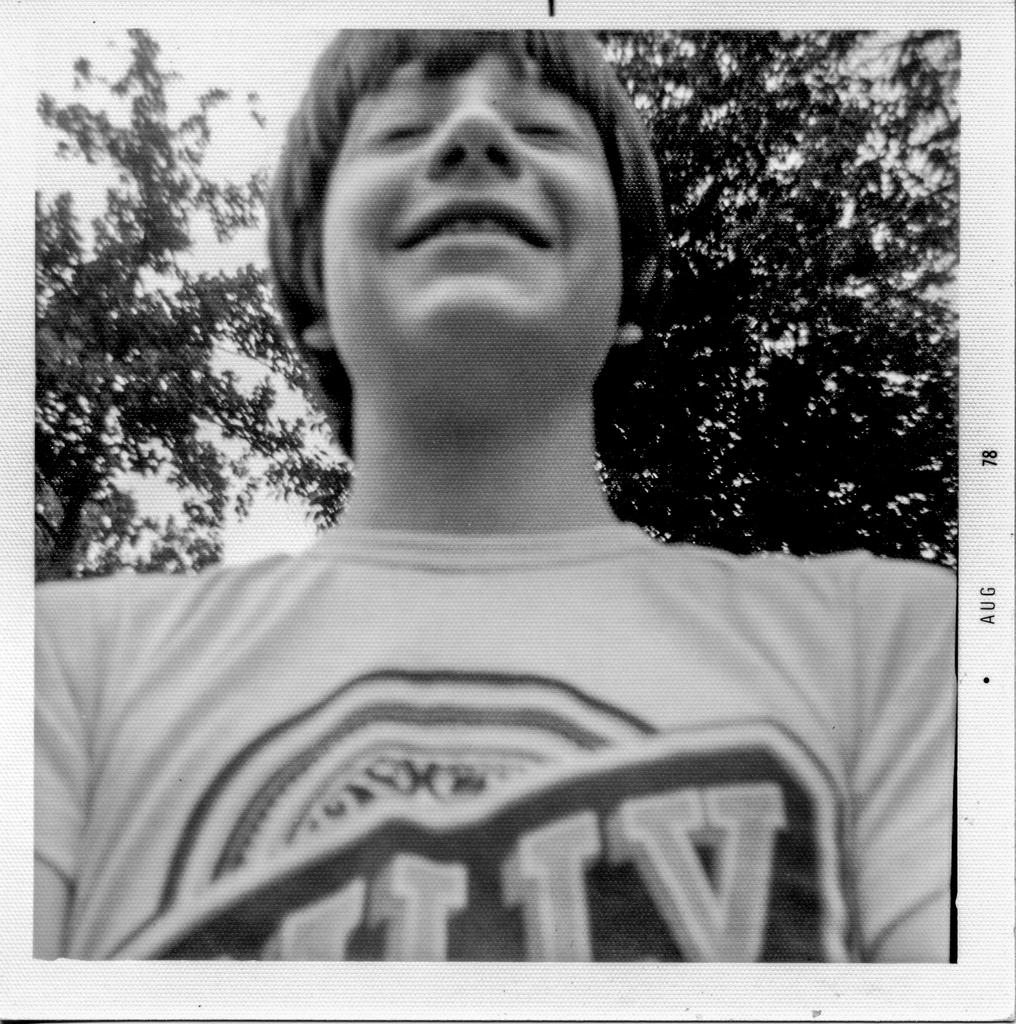Who is the main subject in the picture? There is a boy in the picture. What is the boy doing in the picture? The boy is standing in the picture. What is the boy wearing in the picture? The boy is wearing a T-shirt in the picture. What expression does the boy have in the picture? The boy is smiling in the picture. What can be seen in the background of the picture? Trees and the sky are visible in the background of the picture. What type of grape is the boy holding in the picture? There is no grape present in the picture; the boy is not holding any fruit. 